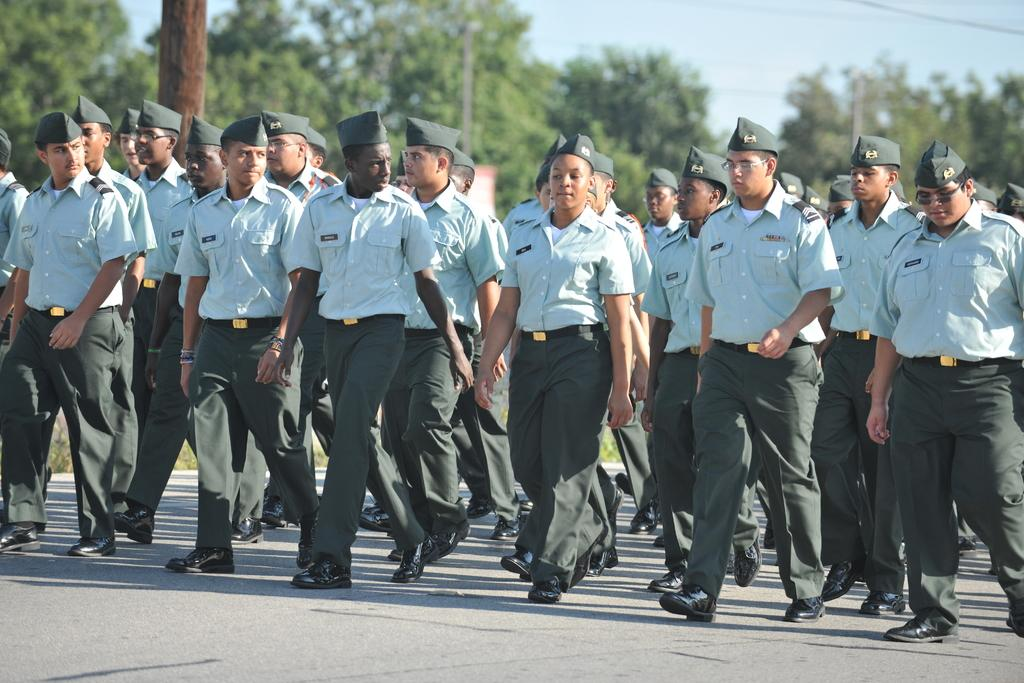What are the people in the image doing? The people in the image are walking on the road. What can be seen behind the people? There are trees behind the people. What objects are visible in the image besides the people and trees? There are poles visible in the image. What is attached to the poles in the image? There are wires at the top of the image. What is visible in the sky in the image? There are clouds visible in the image. What part of the sky is visible in the image? The sky is visible at the top of the image. Can you see any magic happening in the image? There is no magic present in the image. Can you touch the clouds in the image? The clouds in the image are not within reach, so they cannot be touched. 